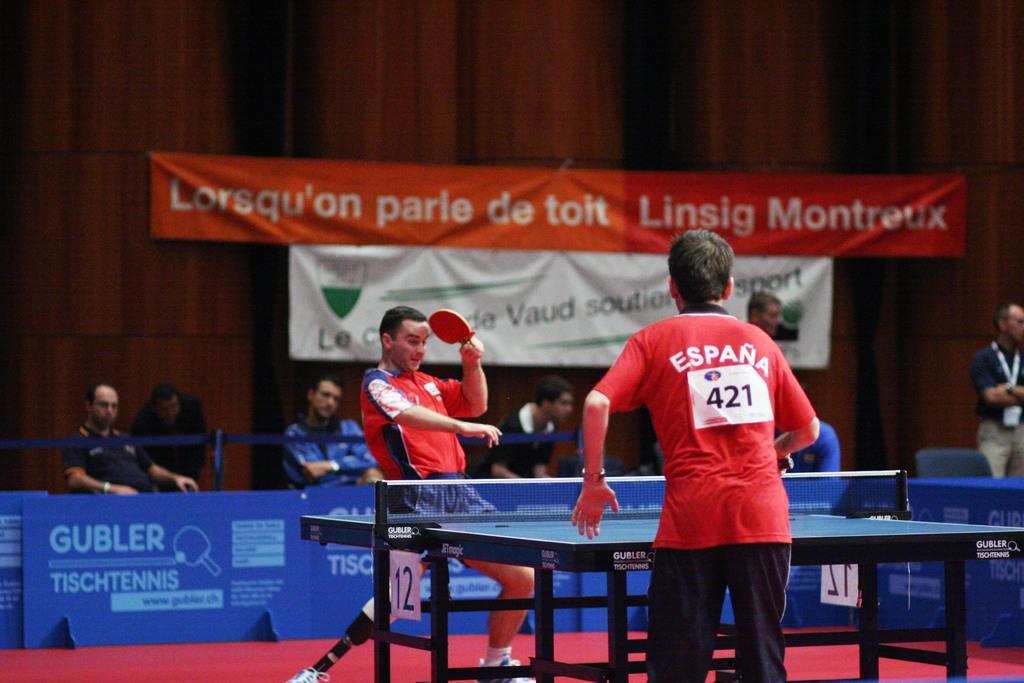In one or two sentences, can you explain what this image depicts? In this image there is a person with red t- shirt, he is holding the bat with his left hand and he is playing table tennis. At the back there are group of people sitting and watching. At the top there are banners, at the bottom there are hoardings and in the middle there is a table. 